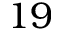<formula> <loc_0><loc_0><loc_500><loc_500>1 9</formula> 